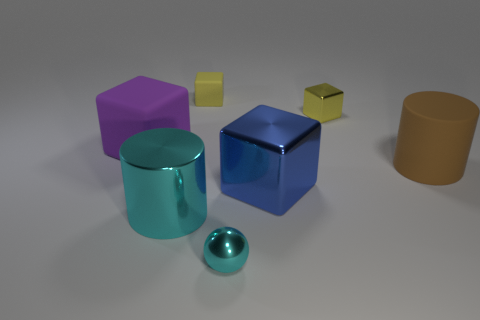Subtract all large blue cubes. How many cubes are left? 3 Add 3 large metal blocks. How many objects exist? 10 Subtract all cyan cylinders. How many cylinders are left? 1 Subtract all cylinders. How many objects are left? 5 Subtract all red balls. Subtract all green cubes. How many balls are left? 1 Subtract all gray spheres. How many brown cylinders are left? 1 Subtract all blocks. Subtract all purple rubber cylinders. How many objects are left? 3 Add 6 large blue things. How many large blue things are left? 7 Add 7 brown objects. How many brown objects exist? 8 Subtract 0 green spheres. How many objects are left? 7 